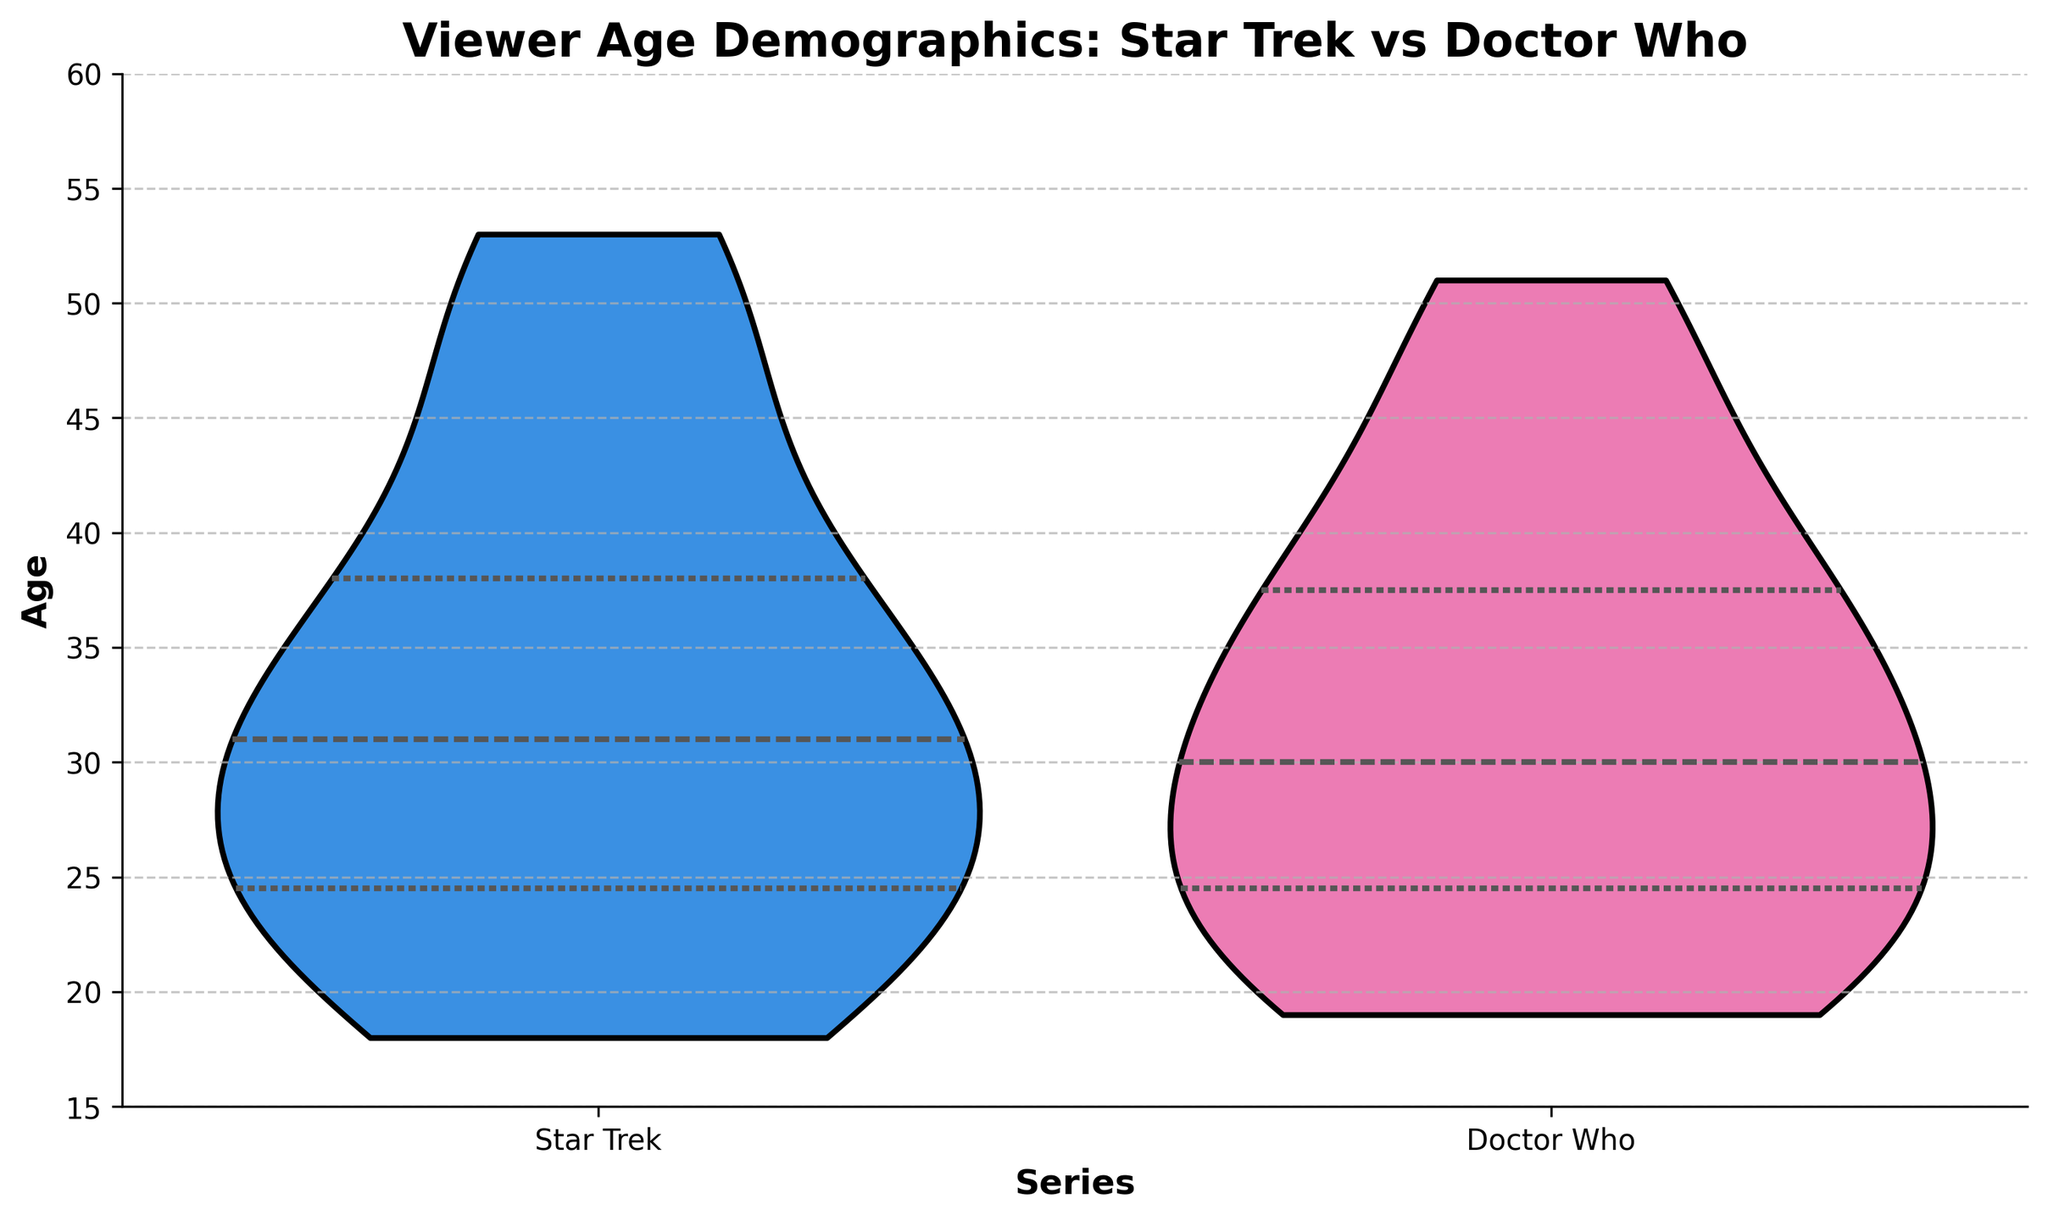What is the title of the figure? The title is located at the top of the figure and usually summarizes its main theme.
Answer: Viewer Age Demographics: Star Trek vs Doctor Who What does the horizontal axis represent? The horizontal axis is labeled and shows the categories being compared in the figure.
Answer: Series What does the vertical axis represent? The vertical axis is labeled and shows the range of values being measured in the figure.
Answer: Age What are the two series compared in the figure? The two series are indicated by the labels under the horizontal axis.
Answer: Star Trek and Doctor Who Which series seems to have a wider spread of ages? By looking at the width and distribution of the violins, we can see which series has more variability.
Answer: Star Trek What is the approximate median age for Doctor Who fans? The violin plot includes a line indicating the median for each series; locate this line within the Doctor Who violin.
Answer: Approximately 30 Which series has a higher median age? Compare the median lines on the violins of both series to determine which one is higher.
Answer: Star Trek What is the approximate age range for Star Trek fans? The violin plot shows the spread of ages; identify the minimum and maximum points for Star Trek fans.
Answer: 18 to 53 What is the maximum age recorded for Doctor Who fans? Look at the top edge of the violin plot for Doctor Who to find the highest age value.
Answer: 51 How do the quartiles differ between the two series? Observe the horizontal lines within each violin that represent the quartiles; compare their positions in both series.
Answer: Star Trek's quartiles are more spread out than Doctor Who’s 